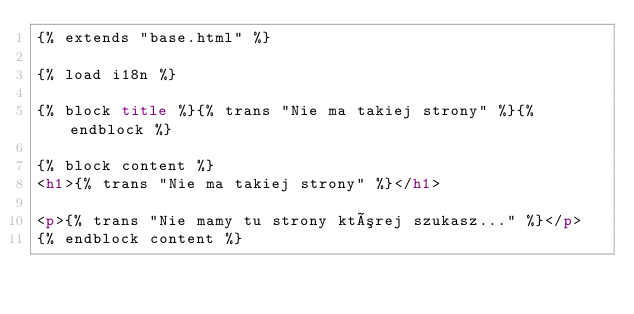<code> <loc_0><loc_0><loc_500><loc_500><_HTML_>{% extends "base.html" %}

{% load i18n %}

{% block title %}{% trans "Nie ma takiej strony" %}{% endblock %}

{% block content %}
<h1>{% trans "Nie ma takiej strony" %}</h1>

<p>{% trans "Nie mamy tu strony której szukasz..." %}</p>
{% endblock content %}
</code> 